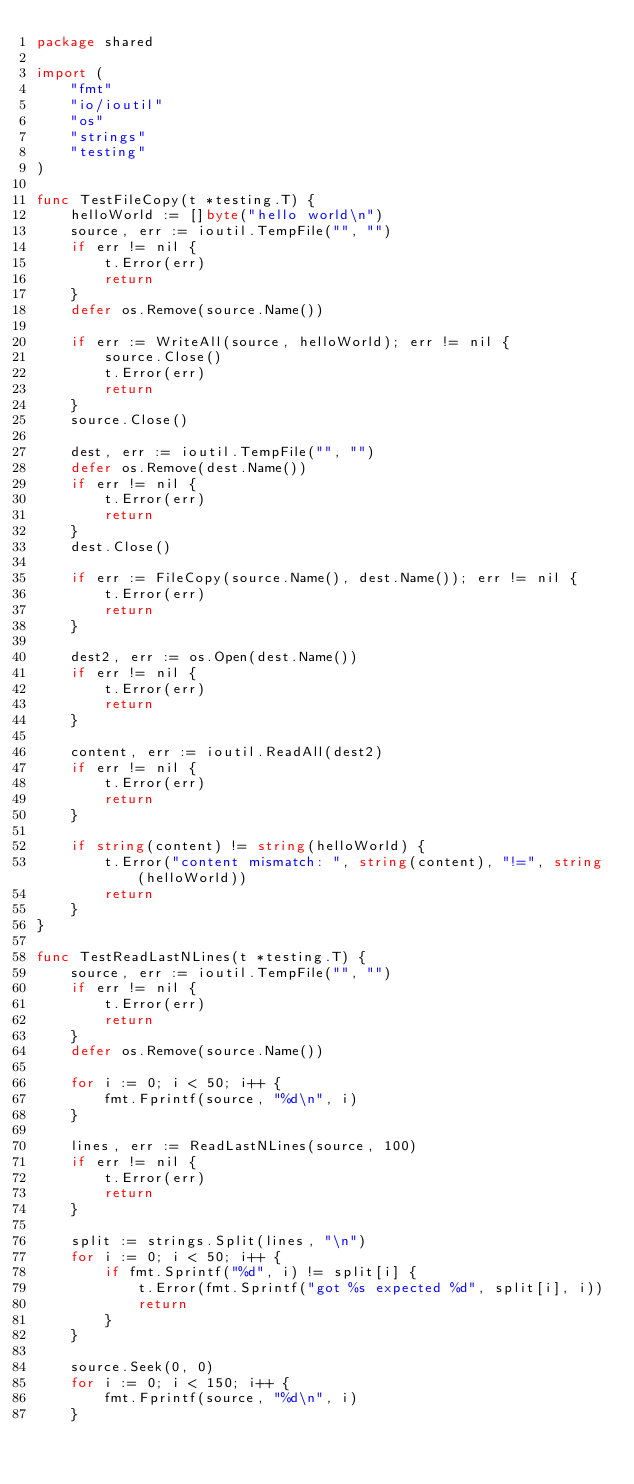<code> <loc_0><loc_0><loc_500><loc_500><_Go_>package shared

import (
	"fmt"
	"io/ioutil"
	"os"
	"strings"
	"testing"
)

func TestFileCopy(t *testing.T) {
	helloWorld := []byte("hello world\n")
	source, err := ioutil.TempFile("", "")
	if err != nil {
		t.Error(err)
		return
	}
	defer os.Remove(source.Name())

	if err := WriteAll(source, helloWorld); err != nil {
		source.Close()
		t.Error(err)
		return
	}
	source.Close()

	dest, err := ioutil.TempFile("", "")
	defer os.Remove(dest.Name())
	if err != nil {
		t.Error(err)
		return
	}
	dest.Close()

	if err := FileCopy(source.Name(), dest.Name()); err != nil {
		t.Error(err)
		return
	}

	dest2, err := os.Open(dest.Name())
	if err != nil {
		t.Error(err)
		return
	}

	content, err := ioutil.ReadAll(dest2)
	if err != nil {
		t.Error(err)
		return
	}

	if string(content) != string(helloWorld) {
		t.Error("content mismatch: ", string(content), "!=", string(helloWorld))
		return
	}
}

func TestReadLastNLines(t *testing.T) {
	source, err := ioutil.TempFile("", "")
	if err != nil {
		t.Error(err)
		return
	}
	defer os.Remove(source.Name())

	for i := 0; i < 50; i++ {
		fmt.Fprintf(source, "%d\n", i)
	}

	lines, err := ReadLastNLines(source, 100)
	if err != nil {
		t.Error(err)
		return
	}

	split := strings.Split(lines, "\n")
	for i := 0; i < 50; i++ {
		if fmt.Sprintf("%d", i) != split[i] {
			t.Error(fmt.Sprintf("got %s expected %d", split[i], i))
			return
		}
	}

	source.Seek(0, 0)
	for i := 0; i < 150; i++ {
		fmt.Fprintf(source, "%d\n", i)
	}
</code> 